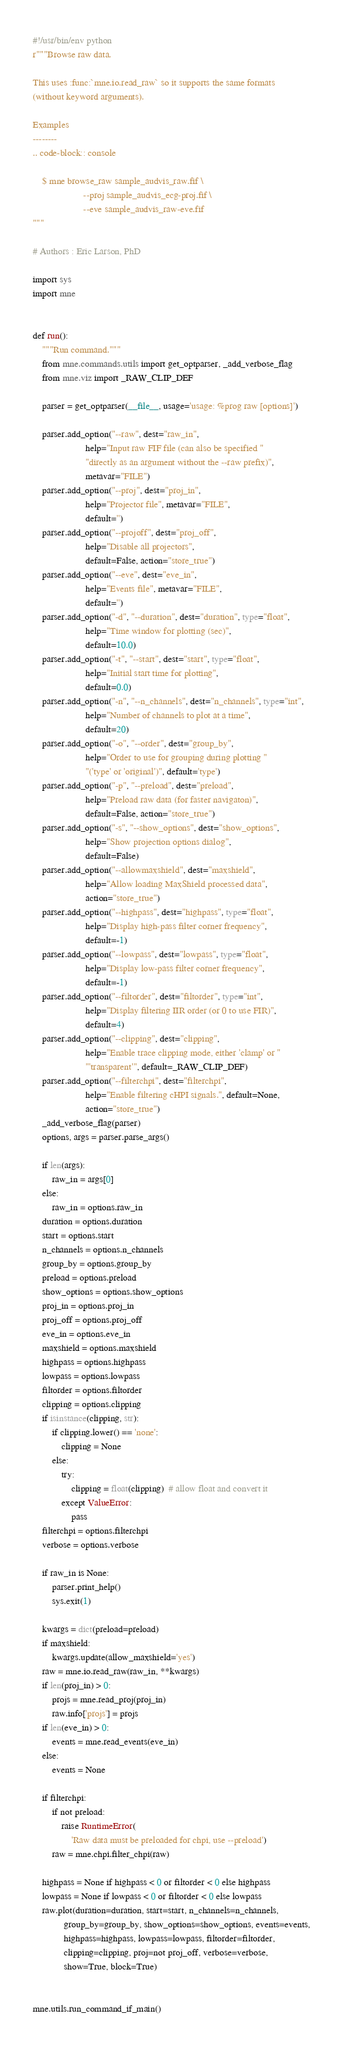Convert code to text. <code><loc_0><loc_0><loc_500><loc_500><_Python_>#!/usr/bin/env python
r"""Browse raw data.

This uses :func:`mne.io.read_raw` so it supports the same formats
(without keyword arguments).

Examples
--------
.. code-block:: console

    $ mne browse_raw sample_audvis_raw.fif \
                     --proj sample_audvis_ecg-proj.fif \
                     --eve sample_audvis_raw-eve.fif
"""

# Authors : Eric Larson, PhD

import sys
import mne


def run():
    """Run command."""
    from mne.commands.utils import get_optparser, _add_verbose_flag
    from mne.viz import _RAW_CLIP_DEF

    parser = get_optparser(__file__, usage='usage: %prog raw [options]')

    parser.add_option("--raw", dest="raw_in",
                      help="Input raw FIF file (can also be specified "
                      "directly as an argument without the --raw prefix)",
                      metavar="FILE")
    parser.add_option("--proj", dest="proj_in",
                      help="Projector file", metavar="FILE",
                      default='')
    parser.add_option("--projoff", dest="proj_off",
                      help="Disable all projectors",
                      default=False, action="store_true")
    parser.add_option("--eve", dest="eve_in",
                      help="Events file", metavar="FILE",
                      default='')
    parser.add_option("-d", "--duration", dest="duration", type="float",
                      help="Time window for plotting (sec)",
                      default=10.0)
    parser.add_option("-t", "--start", dest="start", type="float",
                      help="Initial start time for plotting",
                      default=0.0)
    parser.add_option("-n", "--n_channels", dest="n_channels", type="int",
                      help="Number of channels to plot at a time",
                      default=20)
    parser.add_option("-o", "--order", dest="group_by",
                      help="Order to use for grouping during plotting "
                      "('type' or 'original')", default='type')
    parser.add_option("-p", "--preload", dest="preload",
                      help="Preload raw data (for faster navigaton)",
                      default=False, action="store_true")
    parser.add_option("-s", "--show_options", dest="show_options",
                      help="Show projection options dialog",
                      default=False)
    parser.add_option("--allowmaxshield", dest="maxshield",
                      help="Allow loading MaxShield processed data",
                      action="store_true")
    parser.add_option("--highpass", dest="highpass", type="float",
                      help="Display high-pass filter corner frequency",
                      default=-1)
    parser.add_option("--lowpass", dest="lowpass", type="float",
                      help="Display low-pass filter corner frequency",
                      default=-1)
    parser.add_option("--filtorder", dest="filtorder", type="int",
                      help="Display filtering IIR order (or 0 to use FIR)",
                      default=4)
    parser.add_option("--clipping", dest="clipping",
                      help="Enable trace clipping mode, either 'clamp' or "
                      "'transparent'", default=_RAW_CLIP_DEF)
    parser.add_option("--filterchpi", dest="filterchpi",
                      help="Enable filtering cHPI signals.", default=None,
                      action="store_true")
    _add_verbose_flag(parser)
    options, args = parser.parse_args()

    if len(args):
        raw_in = args[0]
    else:
        raw_in = options.raw_in
    duration = options.duration
    start = options.start
    n_channels = options.n_channels
    group_by = options.group_by
    preload = options.preload
    show_options = options.show_options
    proj_in = options.proj_in
    proj_off = options.proj_off
    eve_in = options.eve_in
    maxshield = options.maxshield
    highpass = options.highpass
    lowpass = options.lowpass
    filtorder = options.filtorder
    clipping = options.clipping
    if isinstance(clipping, str):
        if clipping.lower() == 'none':
            clipping = None
        else:
            try:
                clipping = float(clipping)  # allow float and convert it
            except ValueError:
                pass
    filterchpi = options.filterchpi
    verbose = options.verbose

    if raw_in is None:
        parser.print_help()
        sys.exit(1)

    kwargs = dict(preload=preload)
    if maxshield:
        kwargs.update(allow_maxshield='yes')
    raw = mne.io.read_raw(raw_in, **kwargs)
    if len(proj_in) > 0:
        projs = mne.read_proj(proj_in)
        raw.info['projs'] = projs
    if len(eve_in) > 0:
        events = mne.read_events(eve_in)
    else:
        events = None

    if filterchpi:
        if not preload:
            raise RuntimeError(
                'Raw data must be preloaded for chpi, use --preload')
        raw = mne.chpi.filter_chpi(raw)

    highpass = None if highpass < 0 or filtorder < 0 else highpass
    lowpass = None if lowpass < 0 or filtorder < 0 else lowpass
    raw.plot(duration=duration, start=start, n_channels=n_channels,
             group_by=group_by, show_options=show_options, events=events,
             highpass=highpass, lowpass=lowpass, filtorder=filtorder,
             clipping=clipping, proj=not proj_off, verbose=verbose,
             show=True, block=True)


mne.utils.run_command_if_main()
</code> 